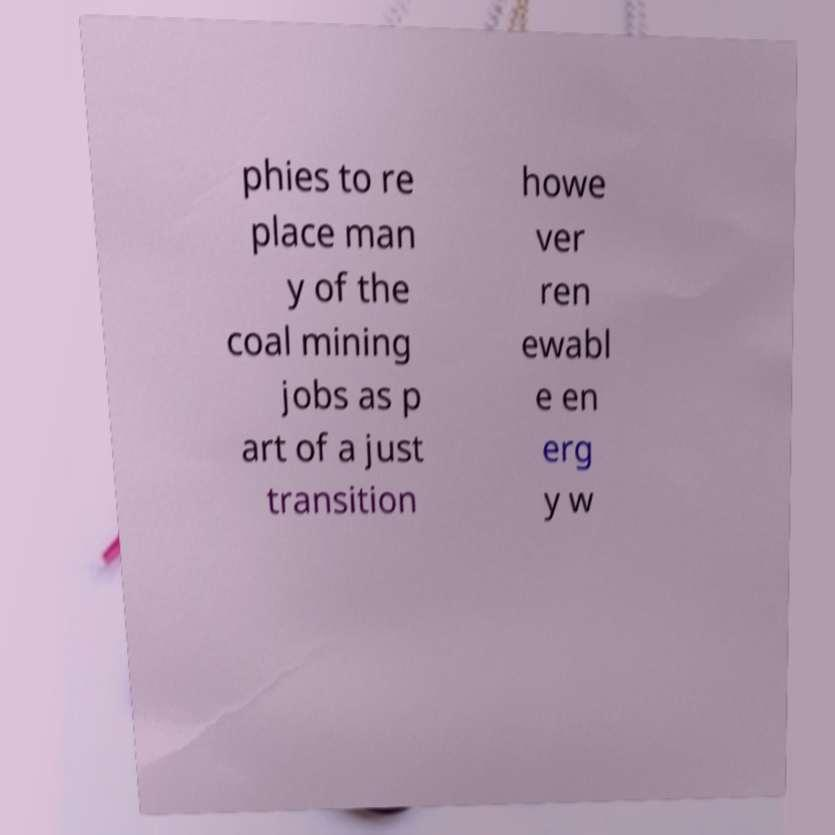Could you assist in decoding the text presented in this image and type it out clearly? phies to re place man y of the coal mining jobs as p art of a just transition howe ver ren ewabl e en erg y w 